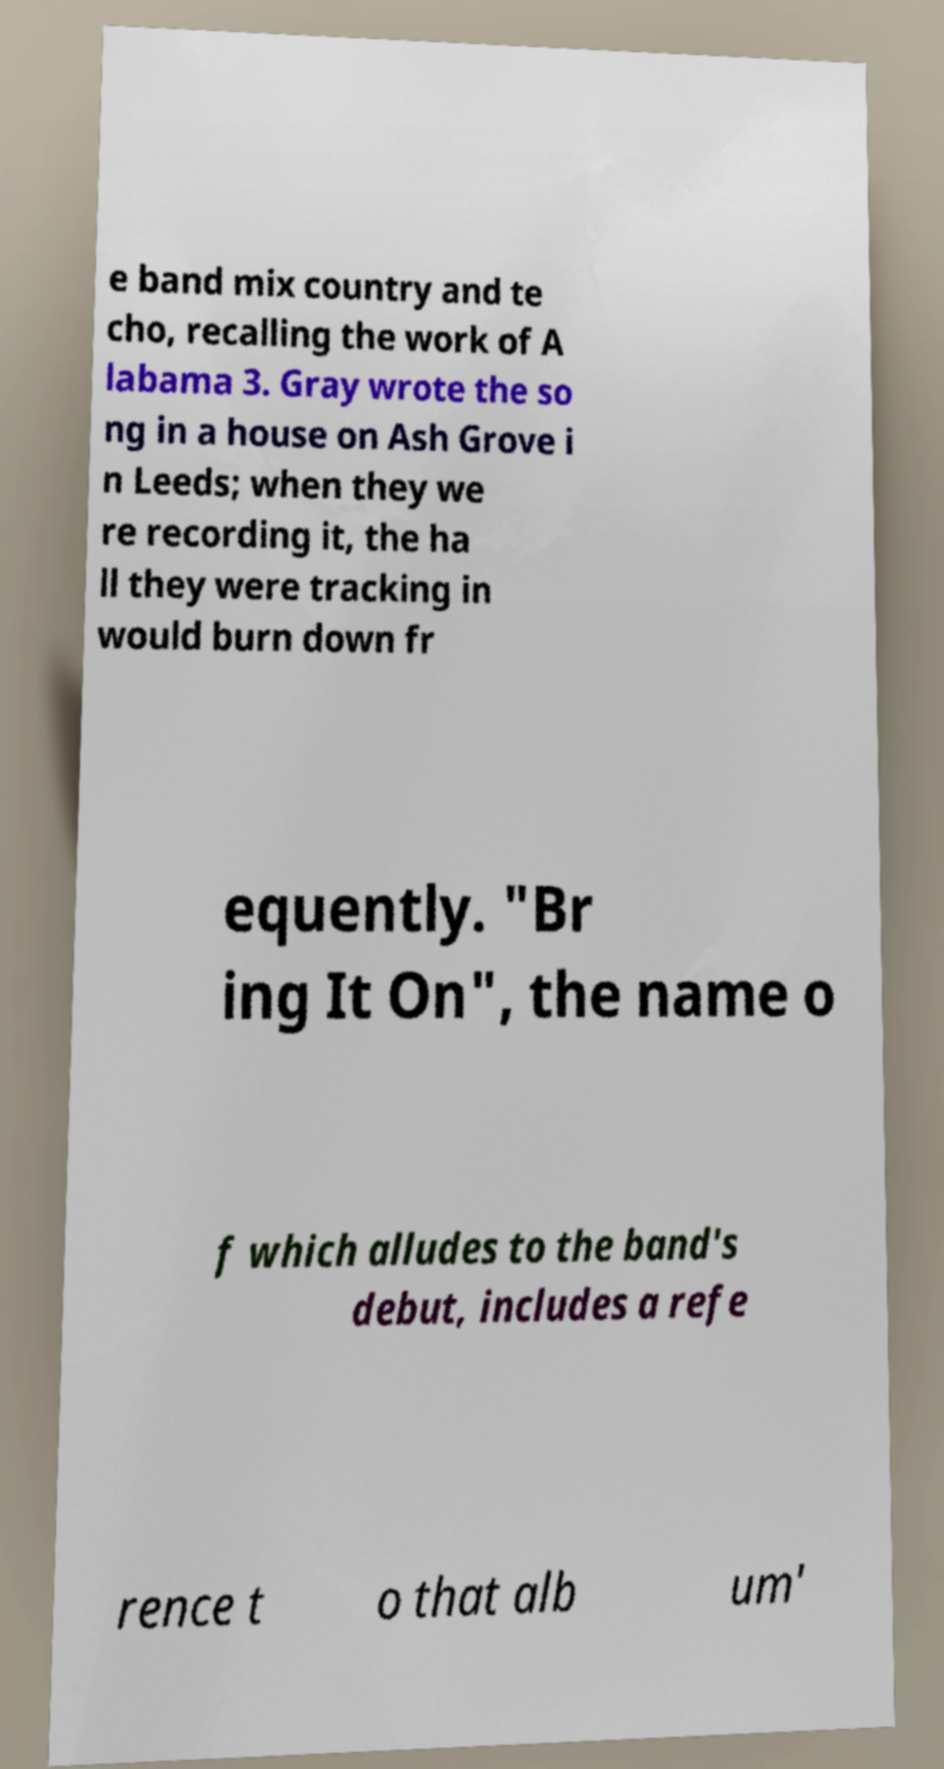Can you read and provide the text displayed in the image?This photo seems to have some interesting text. Can you extract and type it out for me? e band mix country and te cho, recalling the work of A labama 3. Gray wrote the so ng in a house on Ash Grove i n Leeds; when they we re recording it, the ha ll they were tracking in would burn down fr equently. "Br ing It On", the name o f which alludes to the band's debut, includes a refe rence t o that alb um' 